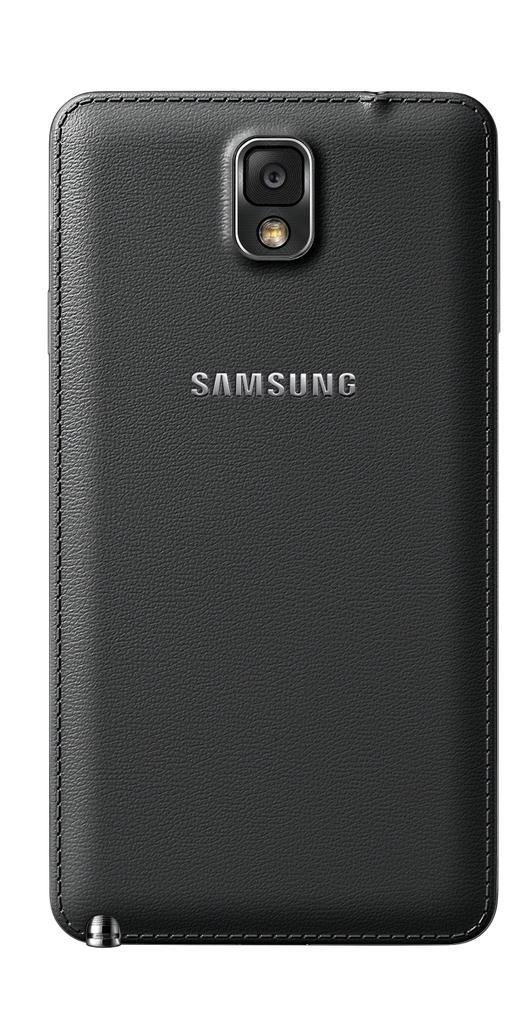Can you describe this image briefly? In this picture we can see back side of a mobile, here we can see a camera, light and some text on it. 